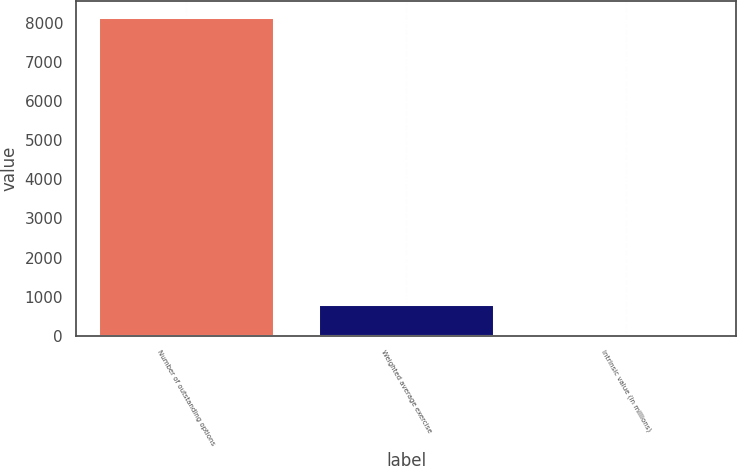Convert chart. <chart><loc_0><loc_0><loc_500><loc_500><bar_chart><fcel>Number of outstanding options<fcel>Weighted average exercise<fcel>Intrinsic value (in millions)<nl><fcel>8139<fcel>824.88<fcel>12.2<nl></chart> 